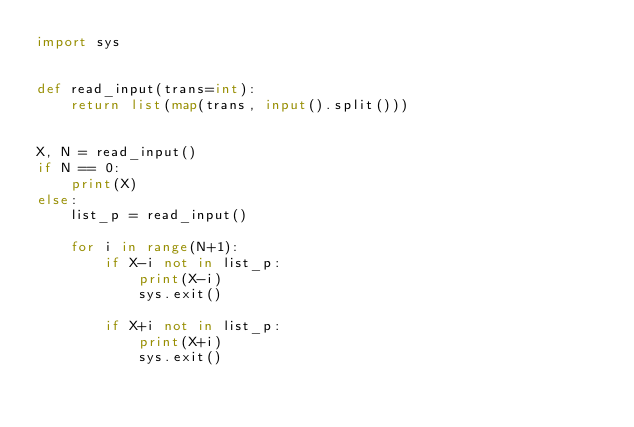Convert code to text. <code><loc_0><loc_0><loc_500><loc_500><_Python_>import sys


def read_input(trans=int):
    return list(map(trans, input().split()))


X, N = read_input()
if N == 0:
    print(X)
else:
    list_p = read_input()

    for i in range(N+1):
        if X-i not in list_p:
            print(X-i)
            sys.exit()

        if X+i not in list_p:
            print(X+i)
            sys.exit()
</code> 